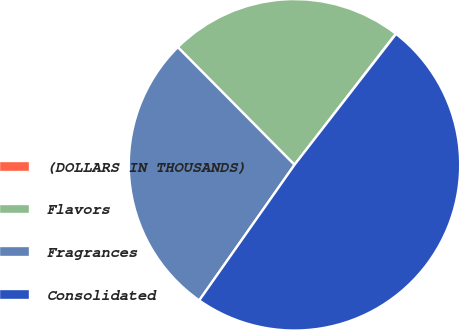<chart> <loc_0><loc_0><loc_500><loc_500><pie_chart><fcel>(DOLLARS IN THOUSANDS)<fcel>Flavors<fcel>Fragrances<fcel>Consolidated<nl><fcel>0.04%<fcel>22.9%<fcel>27.82%<fcel>49.25%<nl></chart> 